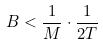Convert formula to latex. <formula><loc_0><loc_0><loc_500><loc_500>B < \frac { 1 } { M } \cdot \frac { 1 } { 2 T }</formula> 